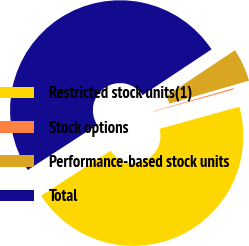Convert chart. <chart><loc_0><loc_0><loc_500><loc_500><pie_chart><fcel>Restricted stock units(1)<fcel>Stock options<fcel>Performance-based stock units<fcel>Total<nl><fcel>45.13%<fcel>0.19%<fcel>4.87%<fcel>49.81%<nl></chart> 